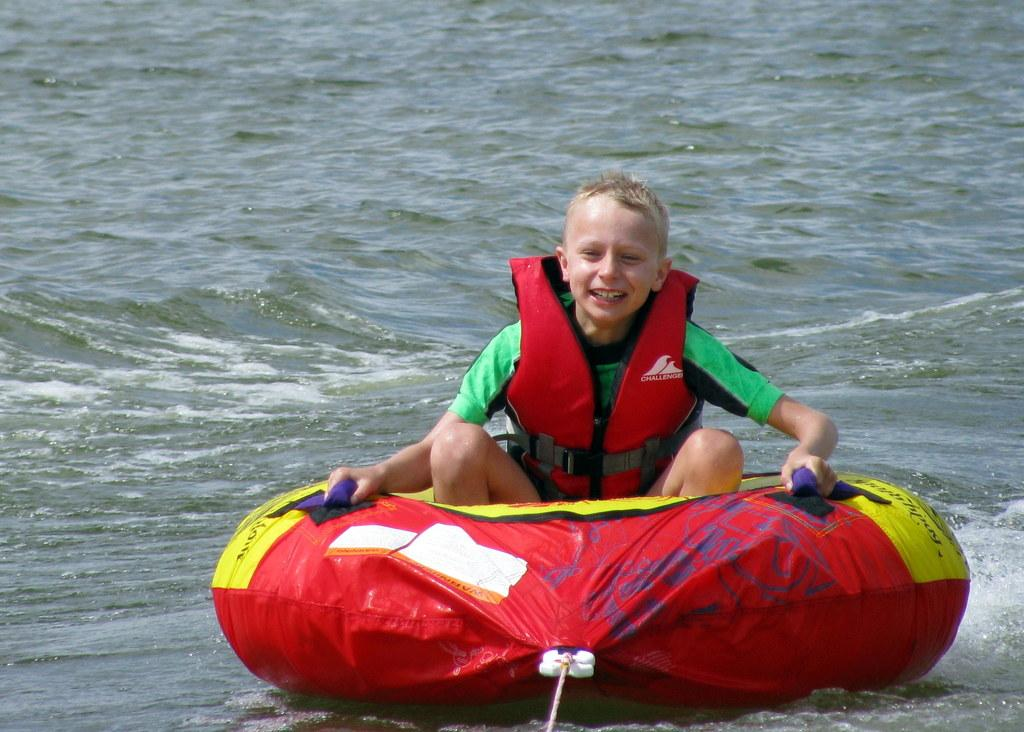Who is the main subject in the image? There is a boy in the image. What is the boy doing in the image? The boy is sitting on an inflatable ring. What is the boy's facial expression in the image? The boy is smiling. What safety precaution is the boy wearing in the image? The boy is wearing a life jacket. What color is the life jacket? The life jacket is red in color. What can be seen in the background of the image? There is an ocean in the background of the image. What type of bulb is illuminating the boy's face in the image? There is no bulb present in the image; it is an outdoor scene with natural lighting from the sun. What valuable jewel is the boy holding in the image? There is no jewel present in the image; the boy is sitting on an inflatable ring and wearing a life jacket. 